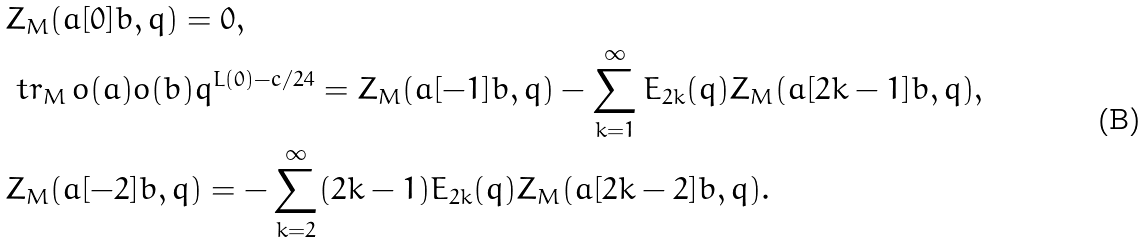<formula> <loc_0><loc_0><loc_500><loc_500>& Z _ { M } ( a [ 0 ] b , q ) = 0 , \\ & \ t r _ { M } \, o ( a ) o ( b ) q ^ { L ( 0 ) - c / 2 4 } = Z _ { M } ( a [ - 1 ] b , q ) - \sum _ { k = 1 } ^ { \infty } { E } _ { 2 k } ( q ) Z _ { M } ( a [ 2 k - 1 ] b , q ) , \\ & Z _ { M } ( a [ - 2 ] b , q ) = - \sum _ { k = 2 } ^ { \infty } ( 2 k - 1 ) { E } _ { 2 k } ( q ) Z _ { M } ( a [ 2 k - 2 ] b , q ) .</formula> 